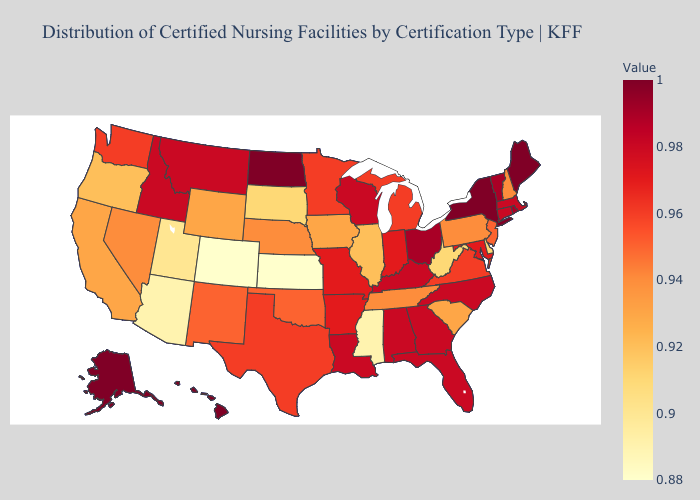Among the states that border New Mexico , which have the highest value?
Answer briefly. Texas. Does Illinois have a higher value than Minnesota?
Be succinct. No. Among the states that border Texas , which have the lowest value?
Concise answer only. New Mexico, Oklahoma. Does Georgia have the highest value in the South?
Quick response, please. Yes. Among the states that border Delaware , does Pennsylvania have the lowest value?
Write a very short answer. Yes. Among the states that border Mississippi , which have the lowest value?
Short answer required. Tennessee. Does Maine have the lowest value in the Northeast?
Be succinct. No. Which states have the lowest value in the USA?
Concise answer only. Colorado, Kansas. 